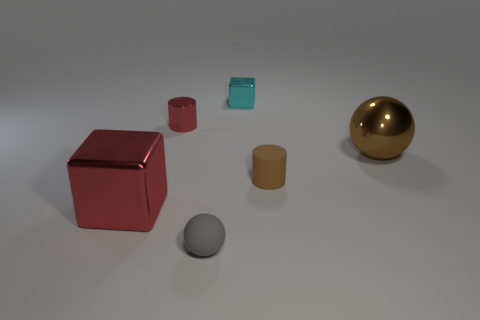What kind of material do these objects appear to be made from, based on the image? Based on their reflection and shine, the objects appear to be made from materials with a glossy finish, possibly metals like aluminum for the grey sphere, or perhaps a polished gold for the gold sphere. The cubes and the cylinder might also be crafted from a painted metal or a high-grade plastic. 